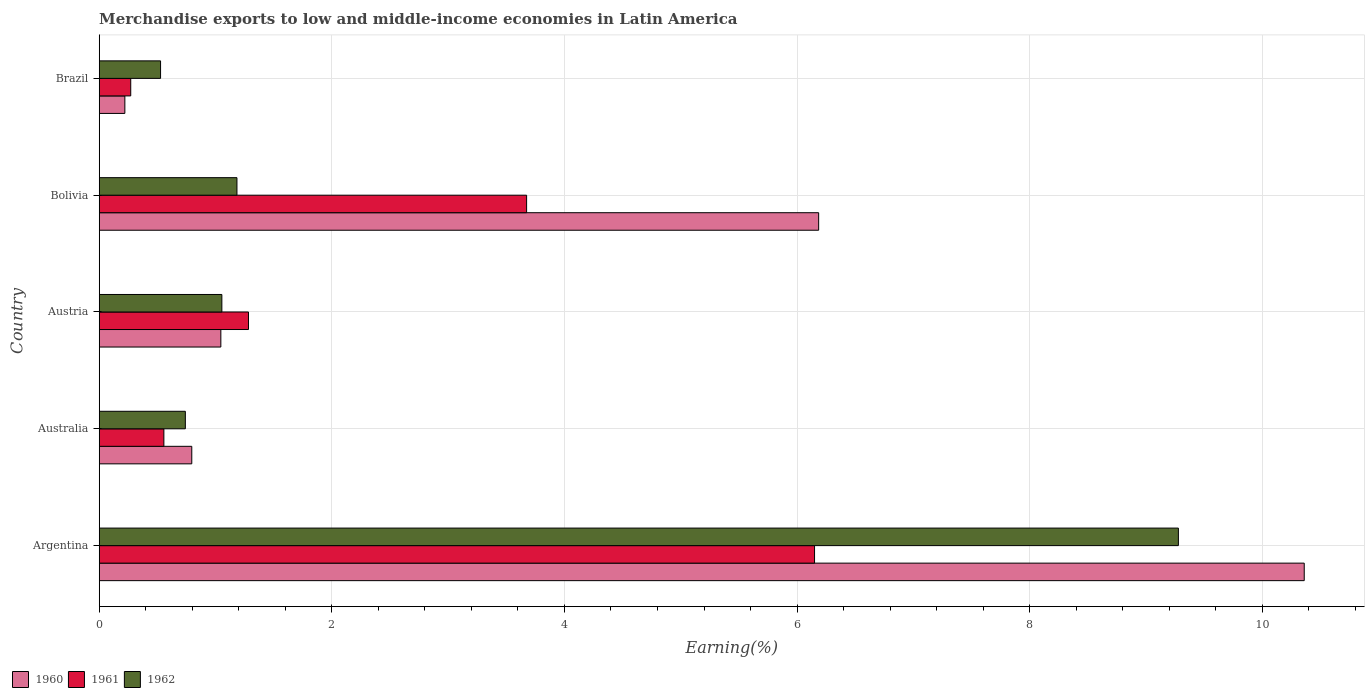Are the number of bars per tick equal to the number of legend labels?
Make the answer very short. Yes. What is the percentage of amount earned from merchandise exports in 1960 in Brazil?
Provide a succinct answer. 0.22. Across all countries, what is the maximum percentage of amount earned from merchandise exports in 1961?
Ensure brevity in your answer.  6.15. Across all countries, what is the minimum percentage of amount earned from merchandise exports in 1961?
Offer a very short reply. 0.27. What is the total percentage of amount earned from merchandise exports in 1961 in the graph?
Ensure brevity in your answer.  11.93. What is the difference between the percentage of amount earned from merchandise exports in 1962 in Argentina and that in Brazil?
Provide a short and direct response. 8.75. What is the difference between the percentage of amount earned from merchandise exports in 1960 in Brazil and the percentage of amount earned from merchandise exports in 1961 in Austria?
Your answer should be compact. -1.06. What is the average percentage of amount earned from merchandise exports in 1962 per country?
Keep it short and to the point. 2.56. What is the difference between the percentage of amount earned from merchandise exports in 1960 and percentage of amount earned from merchandise exports in 1961 in Brazil?
Provide a succinct answer. -0.05. In how many countries, is the percentage of amount earned from merchandise exports in 1962 greater than 7.2 %?
Keep it short and to the point. 1. What is the ratio of the percentage of amount earned from merchandise exports in 1961 in Argentina to that in Austria?
Provide a short and direct response. 4.79. Is the percentage of amount earned from merchandise exports in 1960 in Argentina less than that in Bolivia?
Your answer should be very brief. No. What is the difference between the highest and the second highest percentage of amount earned from merchandise exports in 1961?
Your answer should be very brief. 2.48. What is the difference between the highest and the lowest percentage of amount earned from merchandise exports in 1960?
Keep it short and to the point. 10.14. Is it the case that in every country, the sum of the percentage of amount earned from merchandise exports in 1960 and percentage of amount earned from merchandise exports in 1962 is greater than the percentage of amount earned from merchandise exports in 1961?
Give a very brief answer. Yes. Are all the bars in the graph horizontal?
Give a very brief answer. Yes. What is the difference between two consecutive major ticks on the X-axis?
Offer a terse response. 2. Are the values on the major ticks of X-axis written in scientific E-notation?
Your answer should be very brief. No. Where does the legend appear in the graph?
Offer a terse response. Bottom left. What is the title of the graph?
Provide a short and direct response. Merchandise exports to low and middle-income economies in Latin America. What is the label or title of the X-axis?
Offer a very short reply. Earning(%). What is the Earning(%) in 1960 in Argentina?
Your answer should be very brief. 10.36. What is the Earning(%) of 1961 in Argentina?
Your response must be concise. 6.15. What is the Earning(%) in 1962 in Argentina?
Ensure brevity in your answer.  9.28. What is the Earning(%) of 1960 in Australia?
Your answer should be very brief. 0.8. What is the Earning(%) of 1961 in Australia?
Provide a succinct answer. 0.56. What is the Earning(%) of 1962 in Australia?
Offer a terse response. 0.74. What is the Earning(%) in 1960 in Austria?
Offer a very short reply. 1.05. What is the Earning(%) of 1961 in Austria?
Provide a succinct answer. 1.28. What is the Earning(%) of 1962 in Austria?
Offer a terse response. 1.05. What is the Earning(%) in 1960 in Bolivia?
Offer a very short reply. 6.19. What is the Earning(%) of 1961 in Bolivia?
Provide a succinct answer. 3.67. What is the Earning(%) of 1962 in Bolivia?
Keep it short and to the point. 1.18. What is the Earning(%) of 1960 in Brazil?
Give a very brief answer. 0.22. What is the Earning(%) of 1961 in Brazil?
Provide a short and direct response. 0.27. What is the Earning(%) in 1962 in Brazil?
Keep it short and to the point. 0.53. Across all countries, what is the maximum Earning(%) of 1960?
Your response must be concise. 10.36. Across all countries, what is the maximum Earning(%) of 1961?
Make the answer very short. 6.15. Across all countries, what is the maximum Earning(%) in 1962?
Your answer should be very brief. 9.28. Across all countries, what is the minimum Earning(%) in 1960?
Offer a terse response. 0.22. Across all countries, what is the minimum Earning(%) of 1961?
Make the answer very short. 0.27. Across all countries, what is the minimum Earning(%) of 1962?
Your answer should be compact. 0.53. What is the total Earning(%) of 1960 in the graph?
Offer a very short reply. 18.61. What is the total Earning(%) of 1961 in the graph?
Your answer should be compact. 11.93. What is the total Earning(%) of 1962 in the graph?
Make the answer very short. 12.79. What is the difference between the Earning(%) in 1960 in Argentina and that in Australia?
Your answer should be very brief. 9.56. What is the difference between the Earning(%) in 1961 in Argentina and that in Australia?
Your answer should be very brief. 5.59. What is the difference between the Earning(%) of 1962 in Argentina and that in Australia?
Your answer should be compact. 8.54. What is the difference between the Earning(%) in 1960 in Argentina and that in Austria?
Make the answer very short. 9.31. What is the difference between the Earning(%) in 1961 in Argentina and that in Austria?
Offer a very short reply. 4.87. What is the difference between the Earning(%) of 1962 in Argentina and that in Austria?
Ensure brevity in your answer.  8.22. What is the difference between the Earning(%) in 1960 in Argentina and that in Bolivia?
Keep it short and to the point. 4.17. What is the difference between the Earning(%) in 1961 in Argentina and that in Bolivia?
Your answer should be very brief. 2.48. What is the difference between the Earning(%) in 1962 in Argentina and that in Bolivia?
Keep it short and to the point. 8.09. What is the difference between the Earning(%) of 1960 in Argentina and that in Brazil?
Your response must be concise. 10.14. What is the difference between the Earning(%) in 1961 in Argentina and that in Brazil?
Your answer should be compact. 5.88. What is the difference between the Earning(%) of 1962 in Argentina and that in Brazil?
Your response must be concise. 8.75. What is the difference between the Earning(%) of 1960 in Australia and that in Austria?
Make the answer very short. -0.25. What is the difference between the Earning(%) in 1961 in Australia and that in Austria?
Make the answer very short. -0.73. What is the difference between the Earning(%) of 1962 in Australia and that in Austria?
Your answer should be compact. -0.31. What is the difference between the Earning(%) of 1960 in Australia and that in Bolivia?
Keep it short and to the point. -5.39. What is the difference between the Earning(%) in 1961 in Australia and that in Bolivia?
Provide a short and direct response. -3.12. What is the difference between the Earning(%) of 1962 in Australia and that in Bolivia?
Give a very brief answer. -0.44. What is the difference between the Earning(%) of 1960 in Australia and that in Brazil?
Ensure brevity in your answer.  0.58. What is the difference between the Earning(%) in 1961 in Australia and that in Brazil?
Keep it short and to the point. 0.28. What is the difference between the Earning(%) of 1962 in Australia and that in Brazil?
Make the answer very short. 0.21. What is the difference between the Earning(%) of 1960 in Austria and that in Bolivia?
Give a very brief answer. -5.14. What is the difference between the Earning(%) of 1961 in Austria and that in Bolivia?
Your response must be concise. -2.39. What is the difference between the Earning(%) of 1962 in Austria and that in Bolivia?
Your answer should be very brief. -0.13. What is the difference between the Earning(%) in 1960 in Austria and that in Brazil?
Your answer should be compact. 0.83. What is the difference between the Earning(%) of 1961 in Austria and that in Brazil?
Your response must be concise. 1.01. What is the difference between the Earning(%) of 1962 in Austria and that in Brazil?
Offer a terse response. 0.53. What is the difference between the Earning(%) of 1960 in Bolivia and that in Brazil?
Your answer should be compact. 5.97. What is the difference between the Earning(%) in 1961 in Bolivia and that in Brazil?
Offer a terse response. 3.4. What is the difference between the Earning(%) of 1962 in Bolivia and that in Brazil?
Provide a succinct answer. 0.66. What is the difference between the Earning(%) in 1960 in Argentina and the Earning(%) in 1961 in Australia?
Provide a succinct answer. 9.8. What is the difference between the Earning(%) of 1960 in Argentina and the Earning(%) of 1962 in Australia?
Offer a terse response. 9.62. What is the difference between the Earning(%) in 1961 in Argentina and the Earning(%) in 1962 in Australia?
Give a very brief answer. 5.41. What is the difference between the Earning(%) of 1960 in Argentina and the Earning(%) of 1961 in Austria?
Your answer should be very brief. 9.08. What is the difference between the Earning(%) of 1960 in Argentina and the Earning(%) of 1962 in Austria?
Offer a very short reply. 9.31. What is the difference between the Earning(%) of 1961 in Argentina and the Earning(%) of 1962 in Austria?
Your answer should be very brief. 5.1. What is the difference between the Earning(%) in 1960 in Argentina and the Earning(%) in 1961 in Bolivia?
Your response must be concise. 6.69. What is the difference between the Earning(%) of 1960 in Argentina and the Earning(%) of 1962 in Bolivia?
Give a very brief answer. 9.18. What is the difference between the Earning(%) in 1961 in Argentina and the Earning(%) in 1962 in Bolivia?
Your answer should be compact. 4.97. What is the difference between the Earning(%) in 1960 in Argentina and the Earning(%) in 1961 in Brazil?
Your response must be concise. 10.09. What is the difference between the Earning(%) of 1960 in Argentina and the Earning(%) of 1962 in Brazil?
Give a very brief answer. 9.83. What is the difference between the Earning(%) of 1961 in Argentina and the Earning(%) of 1962 in Brazil?
Make the answer very short. 5.62. What is the difference between the Earning(%) of 1960 in Australia and the Earning(%) of 1961 in Austria?
Offer a very short reply. -0.49. What is the difference between the Earning(%) of 1960 in Australia and the Earning(%) of 1962 in Austria?
Your response must be concise. -0.26. What is the difference between the Earning(%) of 1961 in Australia and the Earning(%) of 1962 in Austria?
Give a very brief answer. -0.5. What is the difference between the Earning(%) in 1960 in Australia and the Earning(%) in 1961 in Bolivia?
Offer a very short reply. -2.88. What is the difference between the Earning(%) of 1960 in Australia and the Earning(%) of 1962 in Bolivia?
Your answer should be compact. -0.39. What is the difference between the Earning(%) in 1961 in Australia and the Earning(%) in 1962 in Bolivia?
Provide a short and direct response. -0.63. What is the difference between the Earning(%) of 1960 in Australia and the Earning(%) of 1961 in Brazil?
Make the answer very short. 0.52. What is the difference between the Earning(%) of 1960 in Australia and the Earning(%) of 1962 in Brazil?
Ensure brevity in your answer.  0.27. What is the difference between the Earning(%) in 1961 in Australia and the Earning(%) in 1962 in Brazil?
Your response must be concise. 0.03. What is the difference between the Earning(%) in 1960 in Austria and the Earning(%) in 1961 in Bolivia?
Your answer should be very brief. -2.63. What is the difference between the Earning(%) of 1960 in Austria and the Earning(%) of 1962 in Bolivia?
Make the answer very short. -0.14. What is the difference between the Earning(%) of 1961 in Austria and the Earning(%) of 1962 in Bolivia?
Offer a terse response. 0.1. What is the difference between the Earning(%) in 1960 in Austria and the Earning(%) in 1961 in Brazil?
Give a very brief answer. 0.77. What is the difference between the Earning(%) in 1960 in Austria and the Earning(%) in 1962 in Brazil?
Ensure brevity in your answer.  0.52. What is the difference between the Earning(%) in 1961 in Austria and the Earning(%) in 1962 in Brazil?
Your answer should be compact. 0.76. What is the difference between the Earning(%) of 1960 in Bolivia and the Earning(%) of 1961 in Brazil?
Offer a terse response. 5.91. What is the difference between the Earning(%) in 1960 in Bolivia and the Earning(%) in 1962 in Brazil?
Your response must be concise. 5.66. What is the difference between the Earning(%) of 1961 in Bolivia and the Earning(%) of 1962 in Brazil?
Your answer should be compact. 3.15. What is the average Earning(%) of 1960 per country?
Make the answer very short. 3.72. What is the average Earning(%) of 1961 per country?
Offer a very short reply. 2.39. What is the average Earning(%) of 1962 per country?
Offer a terse response. 2.56. What is the difference between the Earning(%) in 1960 and Earning(%) in 1961 in Argentina?
Offer a terse response. 4.21. What is the difference between the Earning(%) in 1960 and Earning(%) in 1962 in Argentina?
Ensure brevity in your answer.  1.08. What is the difference between the Earning(%) in 1961 and Earning(%) in 1962 in Argentina?
Make the answer very short. -3.13. What is the difference between the Earning(%) of 1960 and Earning(%) of 1961 in Australia?
Provide a short and direct response. 0.24. What is the difference between the Earning(%) in 1960 and Earning(%) in 1962 in Australia?
Keep it short and to the point. 0.06. What is the difference between the Earning(%) of 1961 and Earning(%) of 1962 in Australia?
Give a very brief answer. -0.18. What is the difference between the Earning(%) of 1960 and Earning(%) of 1961 in Austria?
Ensure brevity in your answer.  -0.24. What is the difference between the Earning(%) in 1960 and Earning(%) in 1962 in Austria?
Your answer should be very brief. -0.01. What is the difference between the Earning(%) in 1961 and Earning(%) in 1962 in Austria?
Offer a very short reply. 0.23. What is the difference between the Earning(%) of 1960 and Earning(%) of 1961 in Bolivia?
Ensure brevity in your answer.  2.51. What is the difference between the Earning(%) in 1960 and Earning(%) in 1962 in Bolivia?
Provide a succinct answer. 5. What is the difference between the Earning(%) in 1961 and Earning(%) in 1962 in Bolivia?
Provide a succinct answer. 2.49. What is the difference between the Earning(%) in 1960 and Earning(%) in 1961 in Brazil?
Make the answer very short. -0.05. What is the difference between the Earning(%) of 1960 and Earning(%) of 1962 in Brazil?
Offer a terse response. -0.31. What is the difference between the Earning(%) in 1961 and Earning(%) in 1962 in Brazil?
Make the answer very short. -0.26. What is the ratio of the Earning(%) in 1960 in Argentina to that in Australia?
Your answer should be very brief. 13.02. What is the ratio of the Earning(%) in 1961 in Argentina to that in Australia?
Your answer should be compact. 11.06. What is the ratio of the Earning(%) of 1962 in Argentina to that in Australia?
Your response must be concise. 12.53. What is the ratio of the Earning(%) in 1960 in Argentina to that in Austria?
Make the answer very short. 9.91. What is the ratio of the Earning(%) of 1961 in Argentina to that in Austria?
Ensure brevity in your answer.  4.79. What is the ratio of the Earning(%) in 1962 in Argentina to that in Austria?
Make the answer very short. 8.8. What is the ratio of the Earning(%) of 1960 in Argentina to that in Bolivia?
Provide a succinct answer. 1.67. What is the ratio of the Earning(%) in 1961 in Argentina to that in Bolivia?
Offer a very short reply. 1.67. What is the ratio of the Earning(%) of 1962 in Argentina to that in Bolivia?
Your response must be concise. 7.84. What is the ratio of the Earning(%) in 1960 in Argentina to that in Brazil?
Your answer should be compact. 46.99. What is the ratio of the Earning(%) of 1961 in Argentina to that in Brazil?
Provide a succinct answer. 22.7. What is the ratio of the Earning(%) of 1962 in Argentina to that in Brazil?
Ensure brevity in your answer.  17.59. What is the ratio of the Earning(%) in 1960 in Australia to that in Austria?
Your answer should be very brief. 0.76. What is the ratio of the Earning(%) of 1961 in Australia to that in Austria?
Provide a short and direct response. 0.43. What is the ratio of the Earning(%) of 1962 in Australia to that in Austria?
Ensure brevity in your answer.  0.7. What is the ratio of the Earning(%) of 1960 in Australia to that in Bolivia?
Ensure brevity in your answer.  0.13. What is the ratio of the Earning(%) in 1961 in Australia to that in Bolivia?
Your answer should be very brief. 0.15. What is the ratio of the Earning(%) in 1962 in Australia to that in Bolivia?
Provide a succinct answer. 0.63. What is the ratio of the Earning(%) of 1960 in Australia to that in Brazil?
Provide a short and direct response. 3.61. What is the ratio of the Earning(%) in 1961 in Australia to that in Brazil?
Provide a succinct answer. 2.05. What is the ratio of the Earning(%) of 1962 in Australia to that in Brazil?
Your response must be concise. 1.4. What is the ratio of the Earning(%) in 1960 in Austria to that in Bolivia?
Offer a terse response. 0.17. What is the ratio of the Earning(%) of 1961 in Austria to that in Bolivia?
Keep it short and to the point. 0.35. What is the ratio of the Earning(%) in 1962 in Austria to that in Bolivia?
Your answer should be very brief. 0.89. What is the ratio of the Earning(%) in 1960 in Austria to that in Brazil?
Your response must be concise. 4.74. What is the ratio of the Earning(%) in 1961 in Austria to that in Brazil?
Provide a short and direct response. 4.74. What is the ratio of the Earning(%) in 1962 in Austria to that in Brazil?
Give a very brief answer. 2. What is the ratio of the Earning(%) in 1960 in Bolivia to that in Brazil?
Your answer should be very brief. 28.05. What is the ratio of the Earning(%) in 1961 in Bolivia to that in Brazil?
Provide a succinct answer. 13.56. What is the ratio of the Earning(%) in 1962 in Bolivia to that in Brazil?
Your answer should be very brief. 2.25. What is the difference between the highest and the second highest Earning(%) in 1960?
Your answer should be very brief. 4.17. What is the difference between the highest and the second highest Earning(%) in 1961?
Your response must be concise. 2.48. What is the difference between the highest and the second highest Earning(%) of 1962?
Provide a short and direct response. 8.09. What is the difference between the highest and the lowest Earning(%) in 1960?
Your response must be concise. 10.14. What is the difference between the highest and the lowest Earning(%) of 1961?
Your answer should be compact. 5.88. What is the difference between the highest and the lowest Earning(%) in 1962?
Make the answer very short. 8.75. 